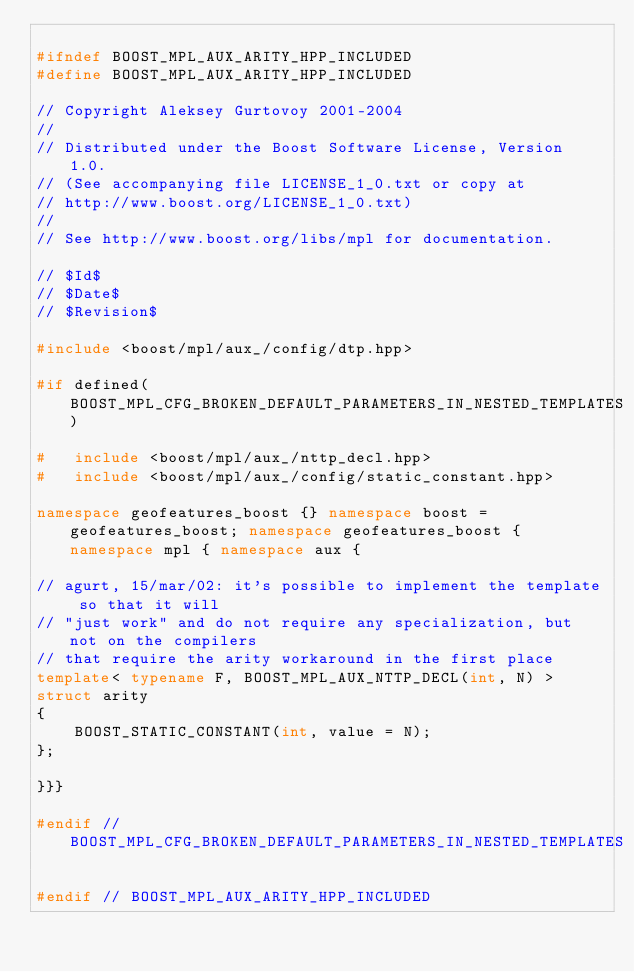<code> <loc_0><loc_0><loc_500><loc_500><_C++_>
#ifndef BOOST_MPL_AUX_ARITY_HPP_INCLUDED
#define BOOST_MPL_AUX_ARITY_HPP_INCLUDED

// Copyright Aleksey Gurtovoy 2001-2004
//
// Distributed under the Boost Software License, Version 1.0. 
// (See accompanying file LICENSE_1_0.txt or copy at 
// http://www.boost.org/LICENSE_1_0.txt)
//
// See http://www.boost.org/libs/mpl for documentation.

// $Id$
// $Date$
// $Revision$

#include <boost/mpl/aux_/config/dtp.hpp>

#if defined(BOOST_MPL_CFG_BROKEN_DEFAULT_PARAMETERS_IN_NESTED_TEMPLATES)

#   include <boost/mpl/aux_/nttp_decl.hpp>
#   include <boost/mpl/aux_/config/static_constant.hpp>

namespace geofeatures_boost {} namespace boost = geofeatures_boost; namespace geofeatures_boost { namespace mpl { namespace aux {

// agurt, 15/mar/02: it's possible to implement the template so that it will 
// "just work" and do not require any specialization, but not on the compilers
// that require the arity workaround in the first place
template< typename F, BOOST_MPL_AUX_NTTP_DECL(int, N) >
struct arity
{
    BOOST_STATIC_CONSTANT(int, value = N);
};

}}}

#endif // BOOST_MPL_CFG_BROKEN_DEFAULT_PARAMETERS_IN_NESTED_TEMPLATES

#endif // BOOST_MPL_AUX_ARITY_HPP_INCLUDED
</code> 